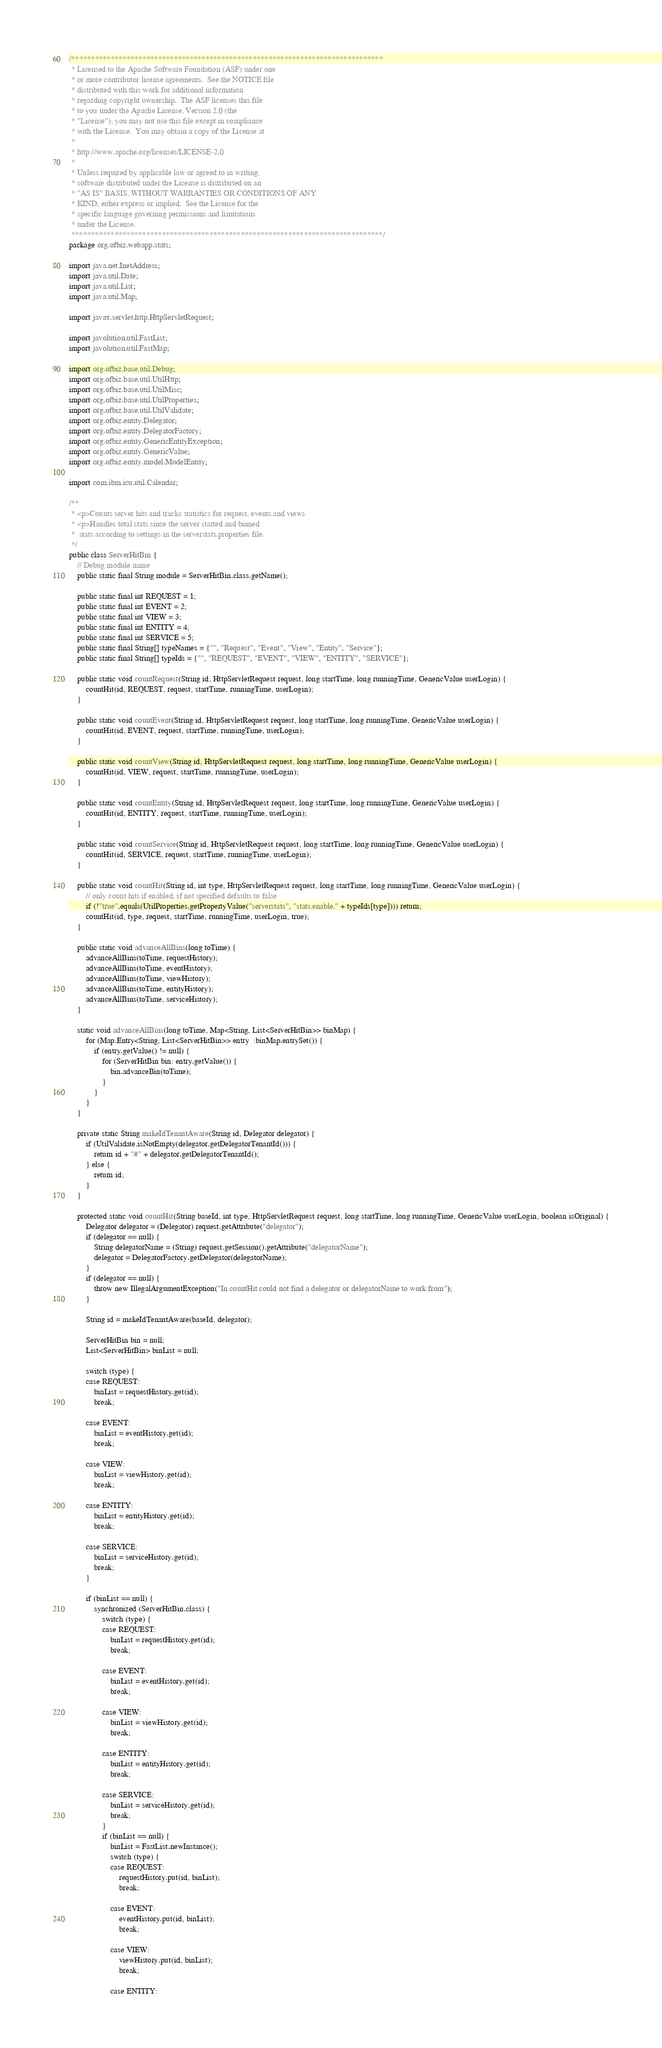Convert code to text. <code><loc_0><loc_0><loc_500><loc_500><_Java_>/*******************************************************************************
 * Licensed to the Apache Software Foundation (ASF) under one
 * or more contributor license agreements.  See the NOTICE file
 * distributed with this work for additional information
 * regarding copyright ownership.  The ASF licenses this file
 * to you under the Apache License, Version 2.0 (the
 * "License"); you may not use this file except in compliance
 * with the License.  You may obtain a copy of the License at
 *
 * http://www.apache.org/licenses/LICENSE-2.0
 *
 * Unless required by applicable law or agreed to in writing,
 * software distributed under the License is distributed on an
 * "AS IS" BASIS, WITHOUT WARRANTIES OR CONDITIONS OF ANY
 * KIND, either express or implied.  See the License for the
 * specific language governing permissions and limitations
 * under the License.
 *******************************************************************************/
package org.ofbiz.webapp.stats;

import java.net.InetAddress;
import java.util.Date;
import java.util.List;
import java.util.Map;

import javax.servlet.http.HttpServletRequest;

import javolution.util.FastList;
import javolution.util.FastMap;

import org.ofbiz.base.util.Debug;
import org.ofbiz.base.util.UtilHttp;
import org.ofbiz.base.util.UtilMisc;
import org.ofbiz.base.util.UtilProperties;
import org.ofbiz.base.util.UtilValidate;
import org.ofbiz.entity.Delegator;
import org.ofbiz.entity.DelegatorFactory;
import org.ofbiz.entity.GenericEntityException;
import org.ofbiz.entity.GenericValue;
import org.ofbiz.entity.model.ModelEntity;

import com.ibm.icu.util.Calendar;

/**
 * <p>Counts server hits and tracks statistics for request, events and views
 * <p>Handles total stats since the server started and binned
 *  stats according to settings in the serverstats.properties file.
 */
public class ServerHitBin {
    // Debug module name
    public static final String module = ServerHitBin.class.getName();

    public static final int REQUEST = 1;
    public static final int EVENT = 2;
    public static final int VIEW = 3;
    public static final int ENTITY = 4;
    public static final int SERVICE = 5;
    public static final String[] typeNames = {"", "Request", "Event", "View", "Entity", "Service"};
    public static final String[] typeIds = {"", "REQUEST", "EVENT", "VIEW", "ENTITY", "SERVICE"};

    public static void countRequest(String id, HttpServletRequest request, long startTime, long runningTime, GenericValue userLogin) {
        countHit(id, REQUEST, request, startTime, runningTime, userLogin);
    }

    public static void countEvent(String id, HttpServletRequest request, long startTime, long runningTime, GenericValue userLogin) {
        countHit(id, EVENT, request, startTime, runningTime, userLogin);
    }

    public static void countView(String id, HttpServletRequest request, long startTime, long runningTime, GenericValue userLogin) {
        countHit(id, VIEW, request, startTime, runningTime, userLogin);
    }

    public static void countEntity(String id, HttpServletRequest request, long startTime, long runningTime, GenericValue userLogin) {
        countHit(id, ENTITY, request, startTime, runningTime, userLogin);
    }

    public static void countService(String id, HttpServletRequest request, long startTime, long runningTime, GenericValue userLogin) {
        countHit(id, SERVICE, request, startTime, runningTime, userLogin);
    }

    public static void countHit(String id, int type, HttpServletRequest request, long startTime, long runningTime, GenericValue userLogin) {
        // only count hits if enabled, if not specified defaults to false
        if (!"true".equals(UtilProperties.getPropertyValue("serverstats", "stats.enable." + typeIds[type]))) return;
        countHit(id, type, request, startTime, runningTime, userLogin, true);
    }

    public static void advanceAllBins(long toTime) {
        advanceAllBins(toTime, requestHistory);
        advanceAllBins(toTime, eventHistory);
        advanceAllBins(toTime, viewHistory);
        advanceAllBins(toTime, entityHistory);
        advanceAllBins(toTime, serviceHistory);
    }

    static void advanceAllBins(long toTime, Map<String, List<ServerHitBin>> binMap) {
        for (Map.Entry<String, List<ServerHitBin>> entry  :binMap.entrySet()) {
            if (entry.getValue() != null) {
                for (ServerHitBin bin: entry.getValue()) {
                    bin.advanceBin(toTime);
                }
            }
        }
    }
    
    private static String makeIdTenantAware(String id, Delegator delegator) {
        if (UtilValidate.isNotEmpty(delegator.getDelegatorTenantId())) {
            return id + "#" + delegator.getDelegatorTenantId();
        } else {
            return id;
        }
    }

    protected static void countHit(String baseId, int type, HttpServletRequest request, long startTime, long runningTime, GenericValue userLogin, boolean isOriginal) {
        Delegator delegator = (Delegator) request.getAttribute("delegator");
        if (delegator == null) {
            String delegatorName = (String) request.getSession().getAttribute("delegatorName");
            delegator = DelegatorFactory.getDelegator(delegatorName);
        }
        if (delegator == null) {
            throw new IllegalArgumentException("In countHit could not find a delegator or delegatorName to work from");
        }
        
        String id = makeIdTenantAware(baseId, delegator);

        ServerHitBin bin = null;
        List<ServerHitBin> binList = null;

        switch (type) {
        case REQUEST:
            binList = requestHistory.get(id);
            break;

        case EVENT:
            binList = eventHistory.get(id);
            break;

        case VIEW:
            binList = viewHistory.get(id);
            break;

        case ENTITY:
            binList = entityHistory.get(id);
            break;

        case SERVICE:
            binList = serviceHistory.get(id);
            break;
        }

        if (binList == null) {
            synchronized (ServerHitBin.class) {
                switch (type) {
                case REQUEST:
                    binList = requestHistory.get(id);
                    break;

                case EVENT:
                    binList = eventHistory.get(id);
                    break;

                case VIEW:
                    binList = viewHistory.get(id);
                    break;

                case ENTITY:
                    binList = entityHistory.get(id);
                    break;

                case SERVICE:
                    binList = serviceHistory.get(id);
                    break;
                }
                if (binList == null) {
                    binList = FastList.newInstance();
                    switch (type) {
                    case REQUEST:
                        requestHistory.put(id, binList);
                        break;

                    case EVENT:
                        eventHistory.put(id, binList);
                        break;

                    case VIEW:
                        viewHistory.put(id, binList);
                        break;

                    case ENTITY:</code> 